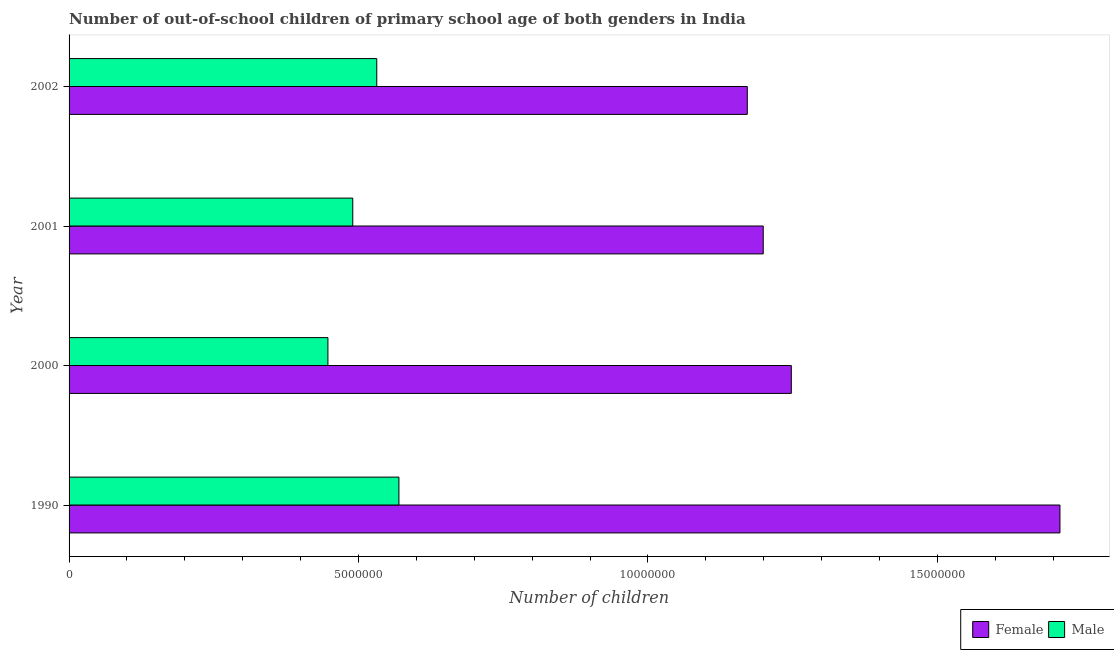How many groups of bars are there?
Provide a short and direct response. 4. Are the number of bars on each tick of the Y-axis equal?
Provide a short and direct response. Yes. How many bars are there on the 3rd tick from the bottom?
Provide a short and direct response. 2. What is the label of the 3rd group of bars from the top?
Offer a terse response. 2000. What is the number of female out-of-school students in 1990?
Offer a very short reply. 1.71e+07. Across all years, what is the maximum number of female out-of-school students?
Provide a succinct answer. 1.71e+07. Across all years, what is the minimum number of male out-of-school students?
Keep it short and to the point. 4.47e+06. In which year was the number of female out-of-school students maximum?
Offer a very short reply. 1990. What is the total number of female out-of-school students in the graph?
Offer a very short reply. 5.33e+07. What is the difference between the number of female out-of-school students in 2000 and that in 2002?
Your answer should be very brief. 7.60e+05. What is the difference between the number of female out-of-school students in 2000 and the number of male out-of-school students in 1990?
Provide a succinct answer. 6.78e+06. What is the average number of female out-of-school students per year?
Your answer should be very brief. 1.33e+07. In the year 2000, what is the difference between the number of female out-of-school students and number of male out-of-school students?
Your answer should be very brief. 8.00e+06. What is the ratio of the number of male out-of-school students in 1990 to that in 2001?
Make the answer very short. 1.16. Is the difference between the number of female out-of-school students in 1990 and 2000 greater than the difference between the number of male out-of-school students in 1990 and 2000?
Offer a terse response. Yes. What is the difference between the highest and the second highest number of male out-of-school students?
Offer a very short reply. 3.83e+05. What is the difference between the highest and the lowest number of female out-of-school students?
Offer a terse response. 5.40e+06. How many years are there in the graph?
Give a very brief answer. 4. Does the graph contain grids?
Offer a terse response. No. Where does the legend appear in the graph?
Offer a very short reply. Bottom right. What is the title of the graph?
Your answer should be compact. Number of out-of-school children of primary school age of both genders in India. Does "Lower secondary education" appear as one of the legend labels in the graph?
Ensure brevity in your answer.  No. What is the label or title of the X-axis?
Your answer should be very brief. Number of children. What is the Number of children of Female in 1990?
Your answer should be compact. 1.71e+07. What is the Number of children in Male in 1990?
Keep it short and to the point. 5.70e+06. What is the Number of children of Female in 2000?
Provide a short and direct response. 1.25e+07. What is the Number of children in Male in 2000?
Make the answer very short. 4.47e+06. What is the Number of children of Female in 2001?
Make the answer very short. 1.20e+07. What is the Number of children of Male in 2001?
Provide a succinct answer. 4.90e+06. What is the Number of children of Female in 2002?
Offer a terse response. 1.17e+07. What is the Number of children of Male in 2002?
Offer a very short reply. 5.32e+06. Across all years, what is the maximum Number of children in Female?
Offer a terse response. 1.71e+07. Across all years, what is the maximum Number of children of Male?
Offer a very short reply. 5.70e+06. Across all years, what is the minimum Number of children of Female?
Give a very brief answer. 1.17e+07. Across all years, what is the minimum Number of children in Male?
Provide a short and direct response. 4.47e+06. What is the total Number of children of Female in the graph?
Ensure brevity in your answer.  5.33e+07. What is the total Number of children of Male in the graph?
Keep it short and to the point. 2.04e+07. What is the difference between the Number of children in Female in 1990 and that in 2000?
Ensure brevity in your answer.  4.64e+06. What is the difference between the Number of children in Male in 1990 and that in 2000?
Your answer should be very brief. 1.23e+06. What is the difference between the Number of children of Female in 1990 and that in 2001?
Offer a very short reply. 5.13e+06. What is the difference between the Number of children in Male in 1990 and that in 2001?
Your answer should be compact. 7.97e+05. What is the difference between the Number of children of Female in 1990 and that in 2002?
Give a very brief answer. 5.40e+06. What is the difference between the Number of children in Male in 1990 and that in 2002?
Keep it short and to the point. 3.83e+05. What is the difference between the Number of children in Female in 2000 and that in 2001?
Ensure brevity in your answer.  4.85e+05. What is the difference between the Number of children in Male in 2000 and that in 2001?
Keep it short and to the point. -4.29e+05. What is the difference between the Number of children of Female in 2000 and that in 2002?
Offer a very short reply. 7.60e+05. What is the difference between the Number of children in Male in 2000 and that in 2002?
Keep it short and to the point. -8.44e+05. What is the difference between the Number of children in Female in 2001 and that in 2002?
Ensure brevity in your answer.  2.76e+05. What is the difference between the Number of children of Male in 2001 and that in 2002?
Give a very brief answer. -4.15e+05. What is the difference between the Number of children of Female in 1990 and the Number of children of Male in 2000?
Offer a very short reply. 1.26e+07. What is the difference between the Number of children in Female in 1990 and the Number of children in Male in 2001?
Provide a succinct answer. 1.22e+07. What is the difference between the Number of children in Female in 1990 and the Number of children in Male in 2002?
Your response must be concise. 1.18e+07. What is the difference between the Number of children in Female in 2000 and the Number of children in Male in 2001?
Your answer should be very brief. 7.58e+06. What is the difference between the Number of children in Female in 2000 and the Number of children in Male in 2002?
Provide a succinct answer. 7.16e+06. What is the difference between the Number of children in Female in 2001 and the Number of children in Male in 2002?
Your answer should be compact. 6.68e+06. What is the average Number of children in Female per year?
Your response must be concise. 1.33e+07. What is the average Number of children of Male per year?
Make the answer very short. 5.10e+06. In the year 1990, what is the difference between the Number of children of Female and Number of children of Male?
Keep it short and to the point. 1.14e+07. In the year 2000, what is the difference between the Number of children of Female and Number of children of Male?
Offer a terse response. 8.00e+06. In the year 2001, what is the difference between the Number of children in Female and Number of children in Male?
Your answer should be very brief. 7.09e+06. In the year 2002, what is the difference between the Number of children in Female and Number of children in Male?
Provide a succinct answer. 6.40e+06. What is the ratio of the Number of children in Female in 1990 to that in 2000?
Make the answer very short. 1.37. What is the ratio of the Number of children in Male in 1990 to that in 2000?
Provide a short and direct response. 1.27. What is the ratio of the Number of children in Female in 1990 to that in 2001?
Your answer should be very brief. 1.43. What is the ratio of the Number of children in Male in 1990 to that in 2001?
Give a very brief answer. 1.16. What is the ratio of the Number of children of Female in 1990 to that in 2002?
Offer a very short reply. 1.46. What is the ratio of the Number of children of Male in 1990 to that in 2002?
Provide a short and direct response. 1.07. What is the ratio of the Number of children in Female in 2000 to that in 2001?
Provide a succinct answer. 1.04. What is the ratio of the Number of children in Male in 2000 to that in 2001?
Your answer should be compact. 0.91. What is the ratio of the Number of children of Female in 2000 to that in 2002?
Offer a terse response. 1.06. What is the ratio of the Number of children of Male in 2000 to that in 2002?
Offer a very short reply. 0.84. What is the ratio of the Number of children in Female in 2001 to that in 2002?
Offer a very short reply. 1.02. What is the ratio of the Number of children of Male in 2001 to that in 2002?
Offer a terse response. 0.92. What is the difference between the highest and the second highest Number of children in Female?
Offer a terse response. 4.64e+06. What is the difference between the highest and the second highest Number of children of Male?
Provide a short and direct response. 3.83e+05. What is the difference between the highest and the lowest Number of children in Female?
Ensure brevity in your answer.  5.40e+06. What is the difference between the highest and the lowest Number of children in Male?
Ensure brevity in your answer.  1.23e+06. 